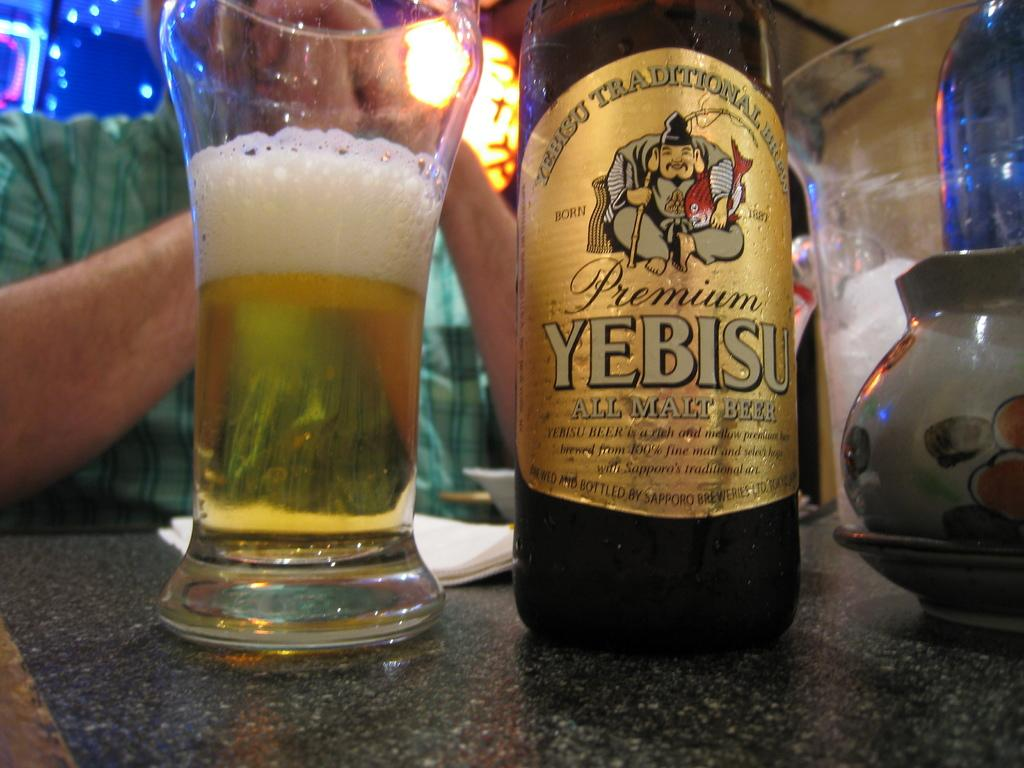<image>
Describe the image concisely. A man is sitting at a table with a half glass, and a bottle, of Premium Yebisu Malt Beer, a Japanese brand. 